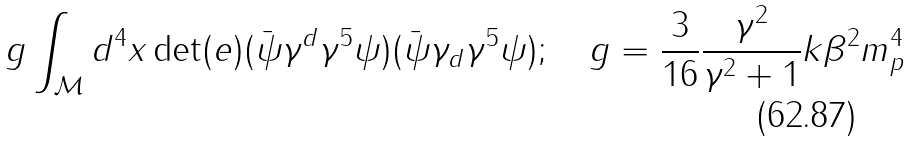<formula> <loc_0><loc_0><loc_500><loc_500>g \int _ { \mathcal { M } } d ^ { 4 } x \det ( e ) ( \bar { \psi } \gamma ^ { d } \gamma ^ { 5 } \psi ) ( \bar { \psi } \gamma _ { d } \gamma ^ { 5 } \psi ) ; \quad g = \frac { 3 } { 1 6 } \frac { \gamma ^ { 2 } } { \gamma ^ { 2 } + 1 } k \beta ^ { 2 } m _ { p } ^ { 4 }</formula> 